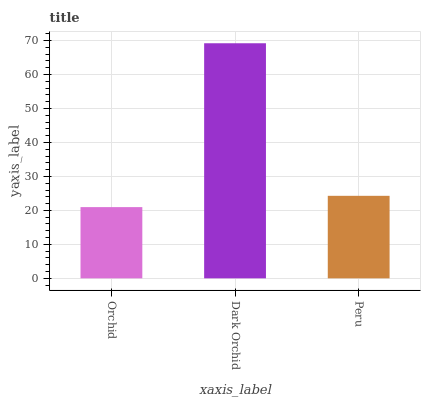Is Orchid the minimum?
Answer yes or no. Yes. Is Dark Orchid the maximum?
Answer yes or no. Yes. Is Peru the minimum?
Answer yes or no. No. Is Peru the maximum?
Answer yes or no. No. Is Dark Orchid greater than Peru?
Answer yes or no. Yes. Is Peru less than Dark Orchid?
Answer yes or no. Yes. Is Peru greater than Dark Orchid?
Answer yes or no. No. Is Dark Orchid less than Peru?
Answer yes or no. No. Is Peru the high median?
Answer yes or no. Yes. Is Peru the low median?
Answer yes or no. Yes. Is Dark Orchid the high median?
Answer yes or no. No. Is Dark Orchid the low median?
Answer yes or no. No. 